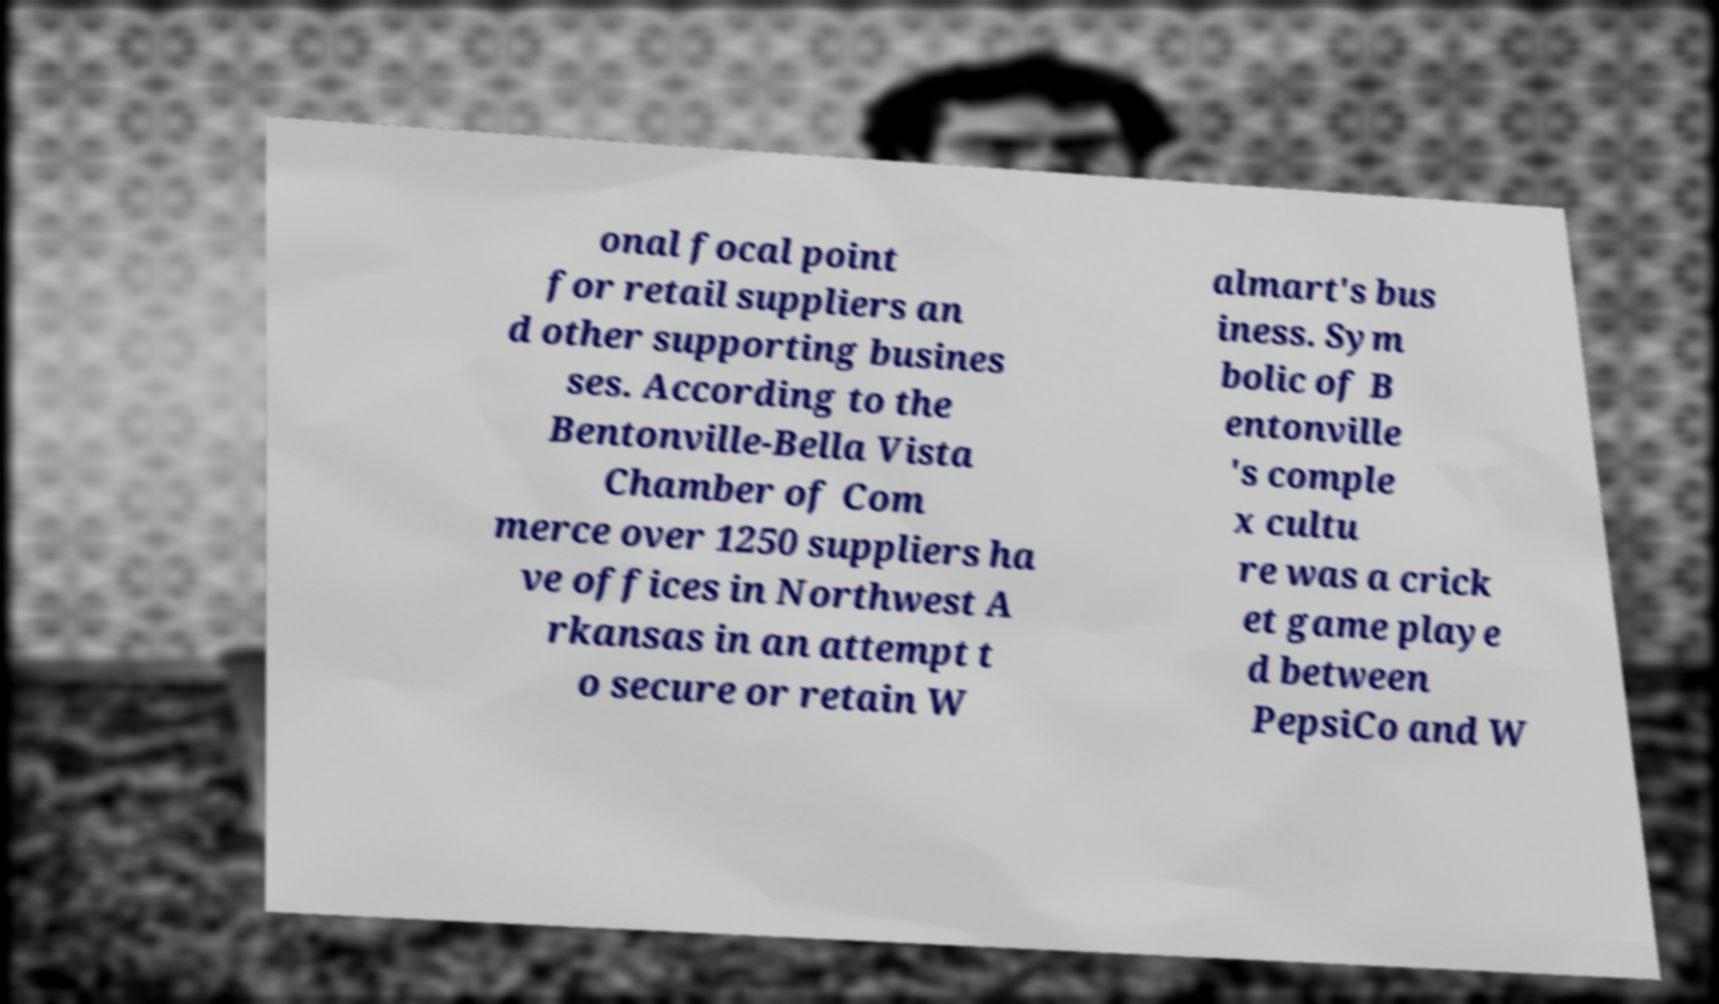Please identify and transcribe the text found in this image. onal focal point for retail suppliers an d other supporting busines ses. According to the Bentonville-Bella Vista Chamber of Com merce over 1250 suppliers ha ve offices in Northwest A rkansas in an attempt t o secure or retain W almart's bus iness. Sym bolic of B entonville 's comple x cultu re was a crick et game playe d between PepsiCo and W 